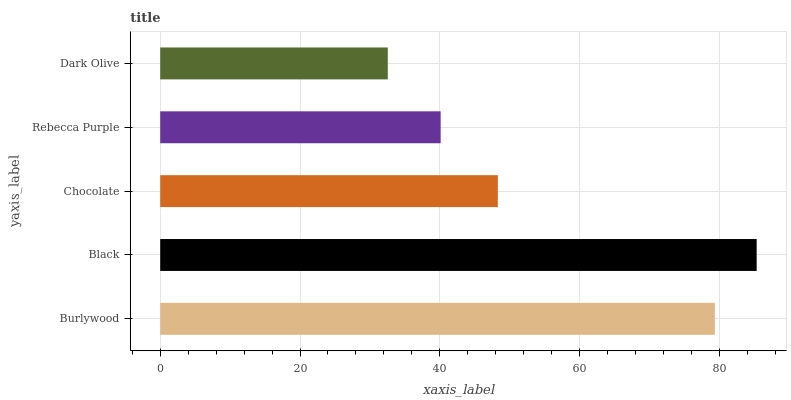Is Dark Olive the minimum?
Answer yes or no. Yes. Is Black the maximum?
Answer yes or no. Yes. Is Chocolate the minimum?
Answer yes or no. No. Is Chocolate the maximum?
Answer yes or no. No. Is Black greater than Chocolate?
Answer yes or no. Yes. Is Chocolate less than Black?
Answer yes or no. Yes. Is Chocolate greater than Black?
Answer yes or no. No. Is Black less than Chocolate?
Answer yes or no. No. Is Chocolate the high median?
Answer yes or no. Yes. Is Chocolate the low median?
Answer yes or no. Yes. Is Burlywood the high median?
Answer yes or no. No. Is Rebecca Purple the low median?
Answer yes or no. No. 